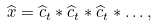<formula> <loc_0><loc_0><loc_500><loc_500>\widehat { x } = \widehat { c } _ { t } \ast \widehat { c } _ { t } \ast \widehat { c } _ { t } \ast \dots ,</formula> 